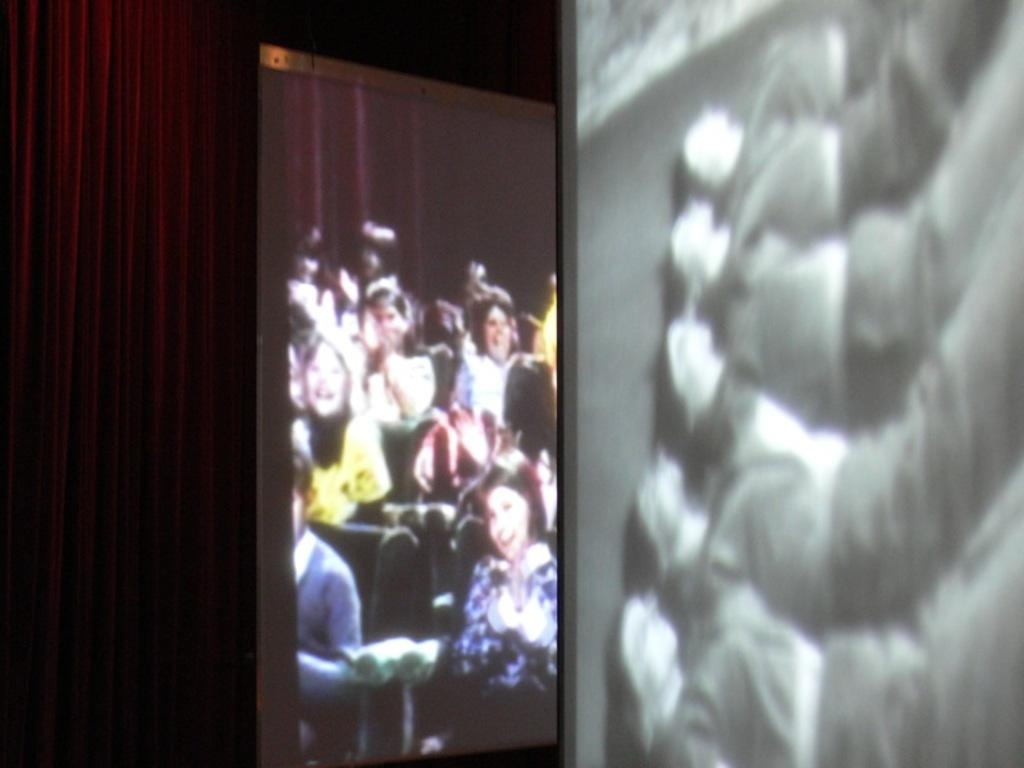What are the people in the image doing? There is a group of people sitting on chairs in the image. What can be seen at the back of the image? There is a curtain at the back of the image. What is located on the right side of the image? There appears to be a screen on the right side of the image. How would you describe the quality of the image? The image is blurry. How many visitors are jumping in the image? There are no visitors or jumping actions depicted in the image. 